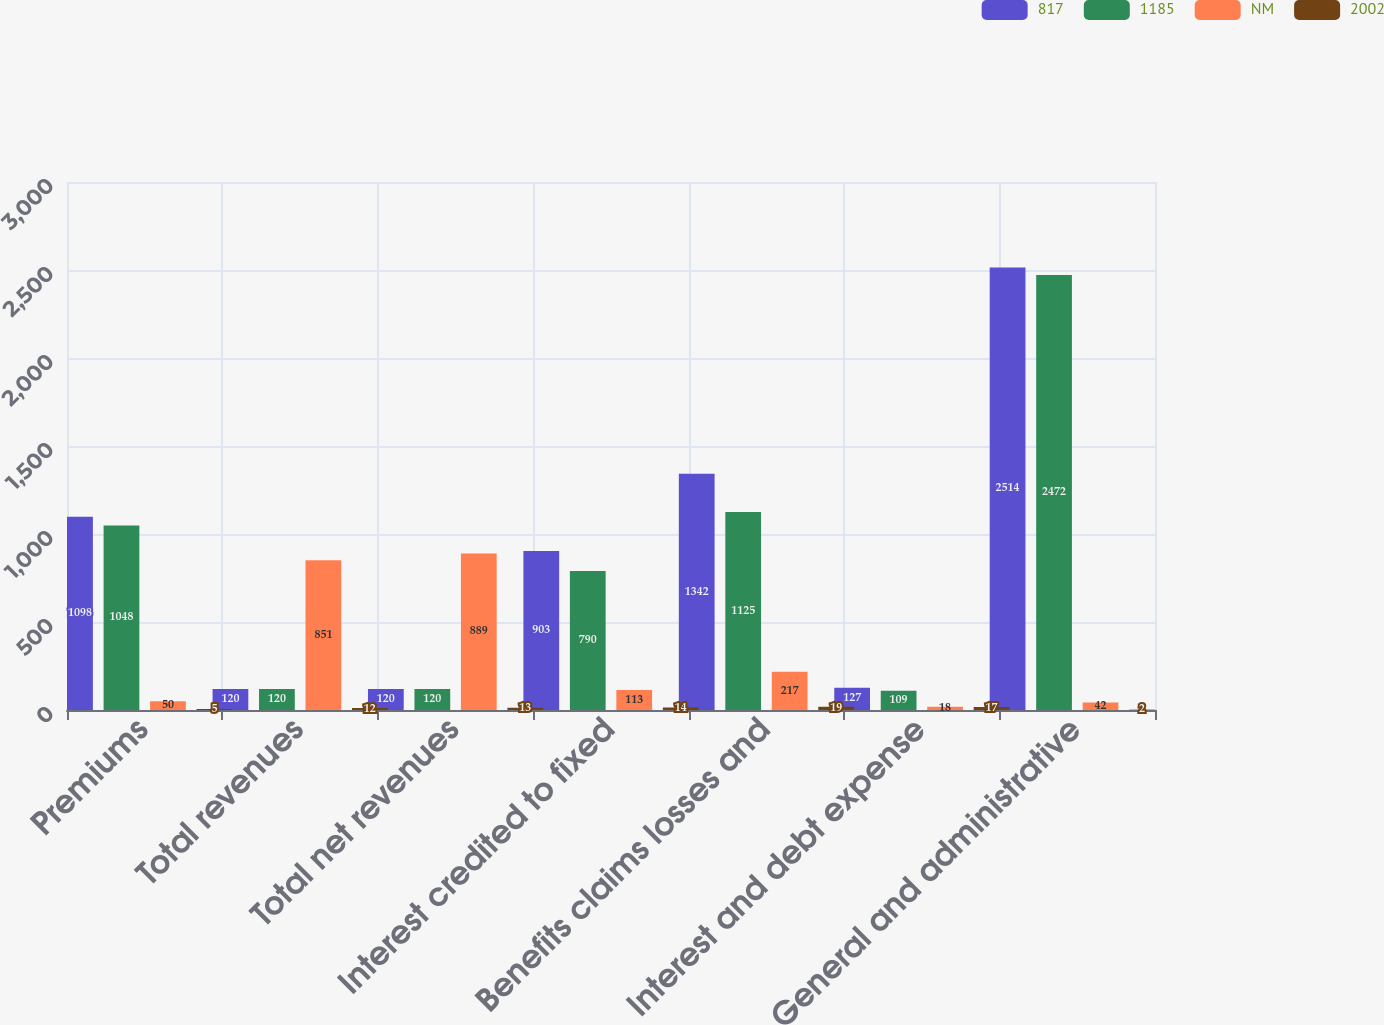<chart> <loc_0><loc_0><loc_500><loc_500><stacked_bar_chart><ecel><fcel>Premiums<fcel>Total revenues<fcel>Total net revenues<fcel>Interest credited to fixed<fcel>Benefits claims losses and<fcel>Interest and debt expense<fcel>General and administrative<nl><fcel>817<fcel>1098<fcel>120<fcel>120<fcel>903<fcel>1342<fcel>127<fcel>2514<nl><fcel>1185<fcel>1048<fcel>120<fcel>120<fcel>790<fcel>1125<fcel>109<fcel>2472<nl><fcel>NM<fcel>50<fcel>851<fcel>889<fcel>113<fcel>217<fcel>18<fcel>42<nl><fcel>2002<fcel>5<fcel>12<fcel>13<fcel>14<fcel>19<fcel>17<fcel>2<nl></chart> 